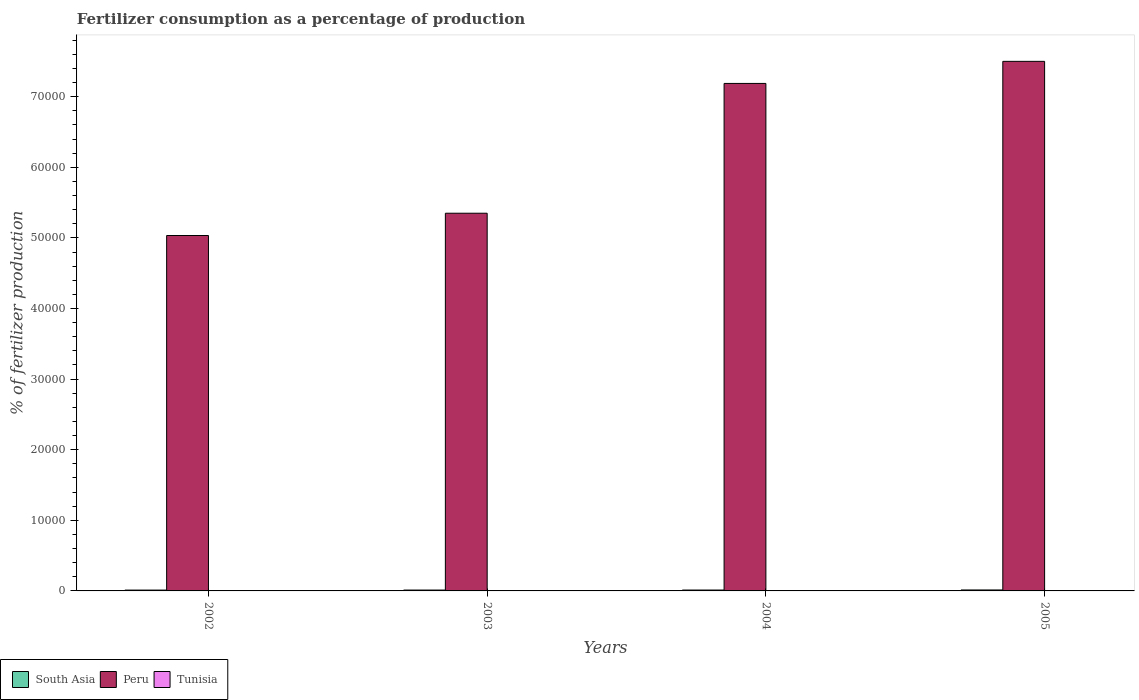How many groups of bars are there?
Your answer should be compact. 4. Are the number of bars per tick equal to the number of legend labels?
Give a very brief answer. Yes. Are the number of bars on each tick of the X-axis equal?
Offer a very short reply. Yes. How many bars are there on the 3rd tick from the right?
Offer a very short reply. 3. What is the percentage of fertilizers consumed in South Asia in 2003?
Make the answer very short. 123.54. Across all years, what is the maximum percentage of fertilizers consumed in South Asia?
Offer a very short reply. 136.23. Across all years, what is the minimum percentage of fertilizers consumed in Tunisia?
Ensure brevity in your answer.  5.63. In which year was the percentage of fertilizers consumed in Tunisia maximum?
Give a very brief answer. 2005. What is the total percentage of fertilizers consumed in Peru in the graph?
Provide a succinct answer. 2.51e+05. What is the difference between the percentage of fertilizers consumed in South Asia in 2004 and that in 2005?
Your answer should be compact. -10.99. What is the difference between the percentage of fertilizers consumed in Peru in 2002 and the percentage of fertilizers consumed in South Asia in 2004?
Your answer should be very brief. 5.02e+04. What is the average percentage of fertilizers consumed in Peru per year?
Make the answer very short. 6.27e+04. In the year 2004, what is the difference between the percentage of fertilizers consumed in Peru and percentage of fertilizers consumed in Tunisia?
Ensure brevity in your answer.  7.19e+04. What is the ratio of the percentage of fertilizers consumed in Tunisia in 2003 to that in 2005?
Keep it short and to the point. 0.51. Is the percentage of fertilizers consumed in South Asia in 2003 less than that in 2004?
Your answer should be very brief. Yes. Is the difference between the percentage of fertilizers consumed in Peru in 2002 and 2005 greater than the difference between the percentage of fertilizers consumed in Tunisia in 2002 and 2005?
Give a very brief answer. No. What is the difference between the highest and the second highest percentage of fertilizers consumed in South Asia?
Give a very brief answer. 10.99. What is the difference between the highest and the lowest percentage of fertilizers consumed in South Asia?
Your answer should be compact. 18.09. Is the sum of the percentage of fertilizers consumed in Tunisia in 2002 and 2004 greater than the maximum percentage of fertilizers consumed in Peru across all years?
Ensure brevity in your answer.  No. What does the 3rd bar from the right in 2002 represents?
Give a very brief answer. South Asia. How many bars are there?
Offer a very short reply. 12. Are all the bars in the graph horizontal?
Provide a short and direct response. No. What is the difference between two consecutive major ticks on the Y-axis?
Provide a succinct answer. 10000. Are the values on the major ticks of Y-axis written in scientific E-notation?
Ensure brevity in your answer.  No. Does the graph contain any zero values?
Your response must be concise. No. Where does the legend appear in the graph?
Your answer should be very brief. Bottom left. How many legend labels are there?
Provide a short and direct response. 3. How are the legend labels stacked?
Your answer should be very brief. Horizontal. What is the title of the graph?
Provide a succinct answer. Fertilizer consumption as a percentage of production. What is the label or title of the Y-axis?
Keep it short and to the point. % of fertilizer production. What is the % of fertilizer production of South Asia in 2002?
Your response must be concise. 118.14. What is the % of fertilizer production of Peru in 2002?
Provide a short and direct response. 5.03e+04. What is the % of fertilizer production of Tunisia in 2002?
Keep it short and to the point. 5.63. What is the % of fertilizer production in South Asia in 2003?
Provide a succinct answer. 123.54. What is the % of fertilizer production in Peru in 2003?
Your response must be concise. 5.35e+04. What is the % of fertilizer production of Tunisia in 2003?
Your answer should be very brief. 7.82. What is the % of fertilizer production of South Asia in 2004?
Offer a terse response. 125.24. What is the % of fertilizer production of Peru in 2004?
Your answer should be compact. 7.19e+04. What is the % of fertilizer production in Tunisia in 2004?
Ensure brevity in your answer.  7.92. What is the % of fertilizer production in South Asia in 2005?
Ensure brevity in your answer.  136.23. What is the % of fertilizer production in Peru in 2005?
Make the answer very short. 7.50e+04. What is the % of fertilizer production of Tunisia in 2005?
Ensure brevity in your answer.  15.18. Across all years, what is the maximum % of fertilizer production in South Asia?
Provide a succinct answer. 136.23. Across all years, what is the maximum % of fertilizer production in Peru?
Your response must be concise. 7.50e+04. Across all years, what is the maximum % of fertilizer production of Tunisia?
Keep it short and to the point. 15.18. Across all years, what is the minimum % of fertilizer production in South Asia?
Your answer should be compact. 118.14. Across all years, what is the minimum % of fertilizer production in Peru?
Your answer should be compact. 5.03e+04. Across all years, what is the minimum % of fertilizer production in Tunisia?
Give a very brief answer. 5.63. What is the total % of fertilizer production in South Asia in the graph?
Your answer should be very brief. 503.15. What is the total % of fertilizer production in Peru in the graph?
Your answer should be very brief. 2.51e+05. What is the total % of fertilizer production in Tunisia in the graph?
Offer a very short reply. 36.55. What is the difference between the % of fertilizer production of South Asia in 2002 and that in 2003?
Offer a terse response. -5.4. What is the difference between the % of fertilizer production of Peru in 2002 and that in 2003?
Provide a succinct answer. -3157.12. What is the difference between the % of fertilizer production in Tunisia in 2002 and that in 2003?
Offer a very short reply. -2.19. What is the difference between the % of fertilizer production of South Asia in 2002 and that in 2004?
Offer a very short reply. -7.1. What is the difference between the % of fertilizer production in Peru in 2002 and that in 2004?
Offer a very short reply. -2.15e+04. What is the difference between the % of fertilizer production of Tunisia in 2002 and that in 2004?
Your response must be concise. -2.29. What is the difference between the % of fertilizer production of South Asia in 2002 and that in 2005?
Keep it short and to the point. -18.09. What is the difference between the % of fertilizer production in Peru in 2002 and that in 2005?
Ensure brevity in your answer.  -2.47e+04. What is the difference between the % of fertilizer production of Tunisia in 2002 and that in 2005?
Ensure brevity in your answer.  -9.56. What is the difference between the % of fertilizer production in South Asia in 2003 and that in 2004?
Your answer should be compact. -1.7. What is the difference between the % of fertilizer production of Peru in 2003 and that in 2004?
Offer a terse response. -1.84e+04. What is the difference between the % of fertilizer production in Tunisia in 2003 and that in 2004?
Offer a terse response. -0.1. What is the difference between the % of fertilizer production in South Asia in 2003 and that in 2005?
Offer a terse response. -12.7. What is the difference between the % of fertilizer production of Peru in 2003 and that in 2005?
Your answer should be compact. -2.15e+04. What is the difference between the % of fertilizer production in Tunisia in 2003 and that in 2005?
Your response must be concise. -7.36. What is the difference between the % of fertilizer production of South Asia in 2004 and that in 2005?
Make the answer very short. -10.99. What is the difference between the % of fertilizer production of Peru in 2004 and that in 2005?
Give a very brief answer. -3126.98. What is the difference between the % of fertilizer production in Tunisia in 2004 and that in 2005?
Offer a terse response. -7.26. What is the difference between the % of fertilizer production of South Asia in 2002 and the % of fertilizer production of Peru in 2003?
Ensure brevity in your answer.  -5.34e+04. What is the difference between the % of fertilizer production of South Asia in 2002 and the % of fertilizer production of Tunisia in 2003?
Provide a succinct answer. 110.32. What is the difference between the % of fertilizer production of Peru in 2002 and the % of fertilizer production of Tunisia in 2003?
Keep it short and to the point. 5.03e+04. What is the difference between the % of fertilizer production of South Asia in 2002 and the % of fertilizer production of Peru in 2004?
Your answer should be very brief. -7.18e+04. What is the difference between the % of fertilizer production in South Asia in 2002 and the % of fertilizer production in Tunisia in 2004?
Make the answer very short. 110.22. What is the difference between the % of fertilizer production of Peru in 2002 and the % of fertilizer production of Tunisia in 2004?
Offer a terse response. 5.03e+04. What is the difference between the % of fertilizer production of South Asia in 2002 and the % of fertilizer production of Peru in 2005?
Provide a short and direct response. -7.49e+04. What is the difference between the % of fertilizer production in South Asia in 2002 and the % of fertilizer production in Tunisia in 2005?
Keep it short and to the point. 102.96. What is the difference between the % of fertilizer production in Peru in 2002 and the % of fertilizer production in Tunisia in 2005?
Provide a succinct answer. 5.03e+04. What is the difference between the % of fertilizer production in South Asia in 2003 and the % of fertilizer production in Peru in 2004?
Ensure brevity in your answer.  -7.18e+04. What is the difference between the % of fertilizer production of South Asia in 2003 and the % of fertilizer production of Tunisia in 2004?
Give a very brief answer. 115.62. What is the difference between the % of fertilizer production in Peru in 2003 and the % of fertilizer production in Tunisia in 2004?
Your response must be concise. 5.35e+04. What is the difference between the % of fertilizer production in South Asia in 2003 and the % of fertilizer production in Peru in 2005?
Offer a very short reply. -7.49e+04. What is the difference between the % of fertilizer production in South Asia in 2003 and the % of fertilizer production in Tunisia in 2005?
Make the answer very short. 108.35. What is the difference between the % of fertilizer production of Peru in 2003 and the % of fertilizer production of Tunisia in 2005?
Keep it short and to the point. 5.35e+04. What is the difference between the % of fertilizer production in South Asia in 2004 and the % of fertilizer production in Peru in 2005?
Give a very brief answer. -7.49e+04. What is the difference between the % of fertilizer production in South Asia in 2004 and the % of fertilizer production in Tunisia in 2005?
Provide a short and direct response. 110.06. What is the difference between the % of fertilizer production in Peru in 2004 and the % of fertilizer production in Tunisia in 2005?
Keep it short and to the point. 7.19e+04. What is the average % of fertilizer production of South Asia per year?
Ensure brevity in your answer.  125.79. What is the average % of fertilizer production of Peru per year?
Make the answer very short. 6.27e+04. What is the average % of fertilizer production of Tunisia per year?
Provide a succinct answer. 9.14. In the year 2002, what is the difference between the % of fertilizer production in South Asia and % of fertilizer production in Peru?
Your answer should be very brief. -5.02e+04. In the year 2002, what is the difference between the % of fertilizer production of South Asia and % of fertilizer production of Tunisia?
Offer a terse response. 112.52. In the year 2002, what is the difference between the % of fertilizer production in Peru and % of fertilizer production in Tunisia?
Give a very brief answer. 5.03e+04. In the year 2003, what is the difference between the % of fertilizer production in South Asia and % of fertilizer production in Peru?
Provide a succinct answer. -5.34e+04. In the year 2003, what is the difference between the % of fertilizer production of South Asia and % of fertilizer production of Tunisia?
Make the answer very short. 115.72. In the year 2003, what is the difference between the % of fertilizer production of Peru and % of fertilizer production of Tunisia?
Make the answer very short. 5.35e+04. In the year 2004, what is the difference between the % of fertilizer production of South Asia and % of fertilizer production of Peru?
Offer a terse response. -7.18e+04. In the year 2004, what is the difference between the % of fertilizer production of South Asia and % of fertilizer production of Tunisia?
Ensure brevity in your answer.  117.32. In the year 2004, what is the difference between the % of fertilizer production in Peru and % of fertilizer production in Tunisia?
Give a very brief answer. 7.19e+04. In the year 2005, what is the difference between the % of fertilizer production in South Asia and % of fertilizer production in Peru?
Your response must be concise. -7.49e+04. In the year 2005, what is the difference between the % of fertilizer production of South Asia and % of fertilizer production of Tunisia?
Give a very brief answer. 121.05. In the year 2005, what is the difference between the % of fertilizer production of Peru and % of fertilizer production of Tunisia?
Make the answer very short. 7.50e+04. What is the ratio of the % of fertilizer production in South Asia in 2002 to that in 2003?
Offer a terse response. 0.96. What is the ratio of the % of fertilizer production in Peru in 2002 to that in 2003?
Provide a succinct answer. 0.94. What is the ratio of the % of fertilizer production in Tunisia in 2002 to that in 2003?
Provide a succinct answer. 0.72. What is the ratio of the % of fertilizer production of South Asia in 2002 to that in 2004?
Your response must be concise. 0.94. What is the ratio of the % of fertilizer production of Peru in 2002 to that in 2004?
Your answer should be very brief. 0.7. What is the ratio of the % of fertilizer production of Tunisia in 2002 to that in 2004?
Offer a terse response. 0.71. What is the ratio of the % of fertilizer production of South Asia in 2002 to that in 2005?
Make the answer very short. 0.87. What is the ratio of the % of fertilizer production in Peru in 2002 to that in 2005?
Give a very brief answer. 0.67. What is the ratio of the % of fertilizer production in Tunisia in 2002 to that in 2005?
Offer a very short reply. 0.37. What is the ratio of the % of fertilizer production of South Asia in 2003 to that in 2004?
Your response must be concise. 0.99. What is the ratio of the % of fertilizer production in Peru in 2003 to that in 2004?
Offer a terse response. 0.74. What is the ratio of the % of fertilizer production of Tunisia in 2003 to that in 2004?
Make the answer very short. 0.99. What is the ratio of the % of fertilizer production of South Asia in 2003 to that in 2005?
Ensure brevity in your answer.  0.91. What is the ratio of the % of fertilizer production in Peru in 2003 to that in 2005?
Make the answer very short. 0.71. What is the ratio of the % of fertilizer production of Tunisia in 2003 to that in 2005?
Offer a terse response. 0.52. What is the ratio of the % of fertilizer production in South Asia in 2004 to that in 2005?
Your answer should be very brief. 0.92. What is the ratio of the % of fertilizer production in Peru in 2004 to that in 2005?
Give a very brief answer. 0.96. What is the ratio of the % of fertilizer production in Tunisia in 2004 to that in 2005?
Provide a short and direct response. 0.52. What is the difference between the highest and the second highest % of fertilizer production in South Asia?
Your answer should be compact. 10.99. What is the difference between the highest and the second highest % of fertilizer production of Peru?
Provide a succinct answer. 3126.98. What is the difference between the highest and the second highest % of fertilizer production of Tunisia?
Your response must be concise. 7.26. What is the difference between the highest and the lowest % of fertilizer production in South Asia?
Give a very brief answer. 18.09. What is the difference between the highest and the lowest % of fertilizer production of Peru?
Provide a short and direct response. 2.47e+04. What is the difference between the highest and the lowest % of fertilizer production in Tunisia?
Offer a terse response. 9.56. 